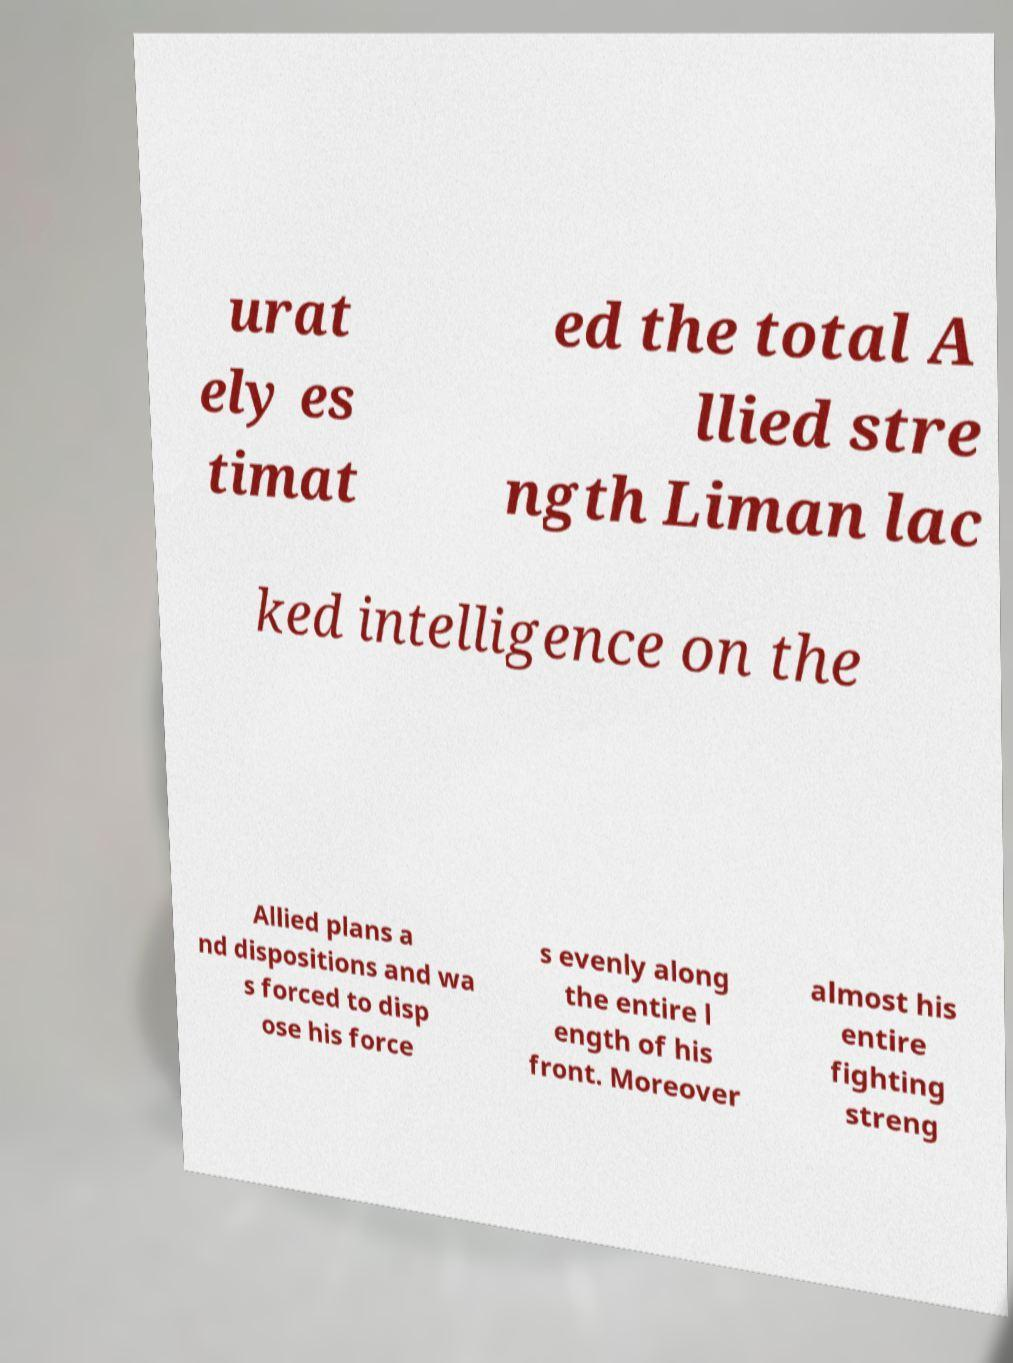Please identify and transcribe the text found in this image. urat ely es timat ed the total A llied stre ngth Liman lac ked intelligence on the Allied plans a nd dispositions and wa s forced to disp ose his force s evenly along the entire l ength of his front. Moreover almost his entire fighting streng 